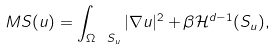Convert formula to latex. <formula><loc_0><loc_0><loc_500><loc_500>M S ( u ) = \int _ { \Omega \ S _ { u } } | \nabla u | ^ { 2 } + \beta \mathcal { H } ^ { d - 1 } ( S _ { u } ) ,</formula> 